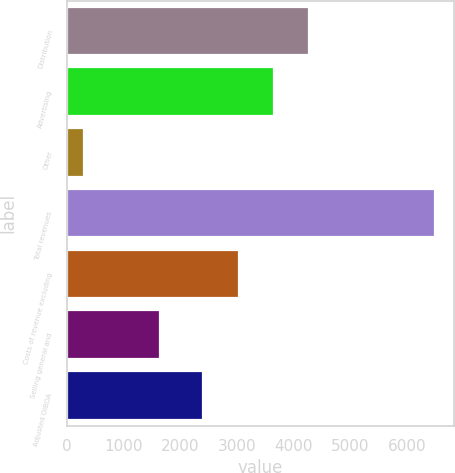<chart> <loc_0><loc_0><loc_500><loc_500><bar_chart><fcel>Distribution<fcel>Advertising<fcel>Other<fcel>Total revenues<fcel>Costs of revenue excluding<fcel>Selling general and<fcel>Adjusted OIBDA<nl><fcel>4267.9<fcel>3649.6<fcel>314<fcel>6497<fcel>3031.3<fcel>1652<fcel>2413<nl></chart> 